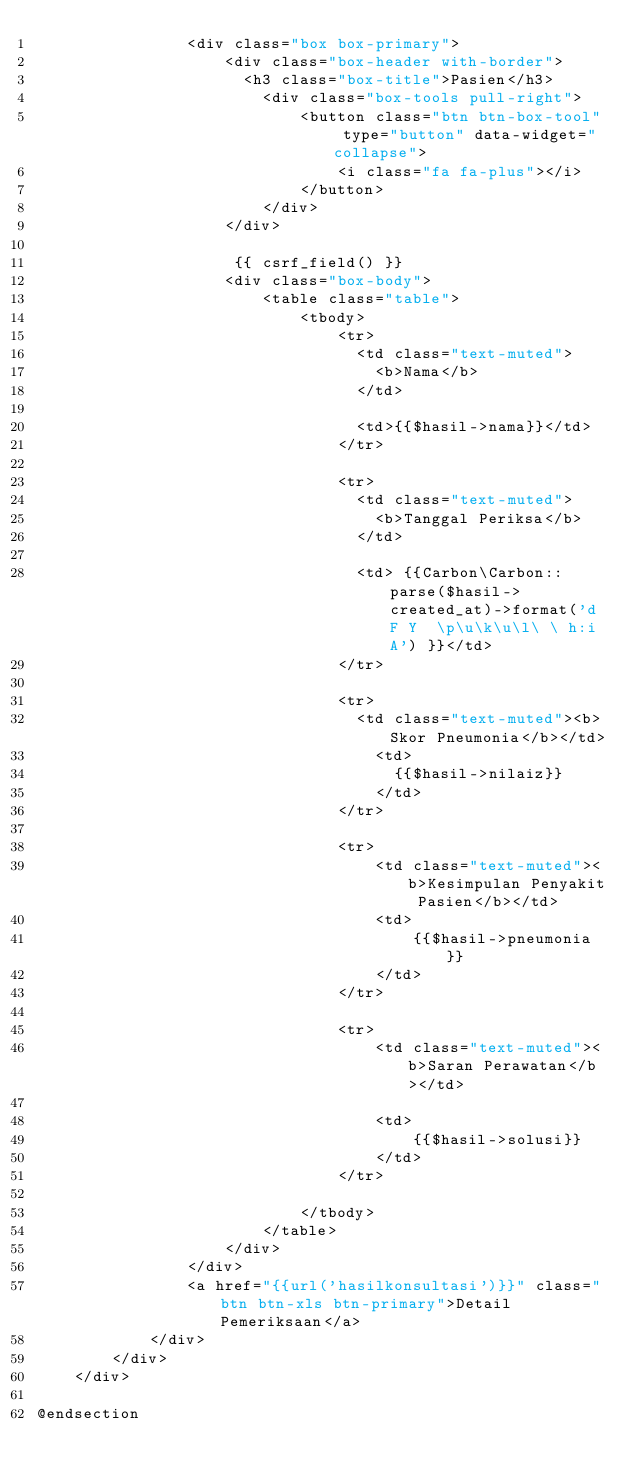<code> <loc_0><loc_0><loc_500><loc_500><_PHP_>                <div class="box box-primary">
                    <div class="box-header with-border">
                      <h3 class="box-title">Pasien</h3> 
                        <div class="box-tools pull-right">
                            <button class="btn btn-box-tool" type="button" data-widget="collapse">
                                <i class="fa fa-plus"></i>
                            </button>
                        </div>
                    </div>

                     {{ csrf_field() }}
                    <div class="box-body">
                        <table class="table">
                            <tbody>
                                <tr>
                                  <td class="text-muted">
                                    <b>Nama</b>    
                                  </td>

                                  <td>{{$hasil->nama}}</td>        
                                </tr>

                                <tr>
                                  <td class="text-muted">
                                    <b>Tanggal Periksa</b>    
                                  </td>

                                  <td> {{Carbon\Carbon::parse($hasil->created_at)->format('d F Y  \p\u\k\u\l\ \ h:i A') }}</td>        
                                </tr>

                                <tr>
                                  <td class="text-muted"><b>Skor Pneumonia</b></td>
                                    <td>
                                      {{$hasil->nilaiz}}
                                    </td>
                                </tr>

                                <tr>
                                    <td class="text-muted"><b>Kesimpulan Penyakit Pasien</b></td>
                                    <td>
                                        {{$hasil->pneumonia}}
                                    </td>
                                </tr>

                                <tr>
                                    <td class="text-muted"><b>Saran Perawatan</b></td>

                                    <td>
                                        {{$hasil->solusi}}
                                    </td>
                                </tr>
                              
                            </tbody>
                        </table> 
                    </div>
                </div> 
                <a href="{{url('hasilkonsultasi')}}" class="btn btn-xls btn-primary">Detail Pemeriksaan</a>   
            </div>
        </div>
    </div> 
  
@endsection</code> 